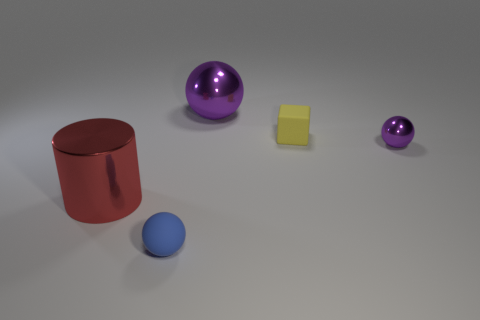Subtract all purple spheres. How many spheres are left? 1 Add 1 small yellow spheres. How many objects exist? 6 Subtract all blue balls. How many balls are left? 2 Subtract all blocks. How many objects are left? 4 Subtract 2 spheres. How many spheres are left? 1 Subtract all tiny yellow cubes. Subtract all blue spheres. How many objects are left? 3 Add 3 purple spheres. How many purple spheres are left? 5 Add 3 purple balls. How many purple balls exist? 5 Subtract 0 yellow cylinders. How many objects are left? 5 Subtract all gray balls. Subtract all gray cylinders. How many balls are left? 3 